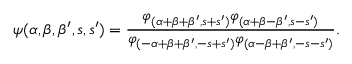<formula> <loc_0><loc_0><loc_500><loc_500>\psi ( \alpha , \beta , \beta ^ { \prime } , s , s ^ { \prime } ) = \frac { \varphi _ { ( \alpha + \beta + \beta ^ { \prime } , s + s ^ { \prime } ) } \varphi _ { ( \alpha + \beta - \beta ^ { \prime } , s - s ^ { \prime } ) } } { \varphi _ { ( - \alpha + \beta + \beta ^ { \prime } , - s + s ^ { \prime } ) } \varphi _ { ( \alpha - \beta + \beta ^ { \prime } , - s - s ^ { \prime } ) } } .</formula> 